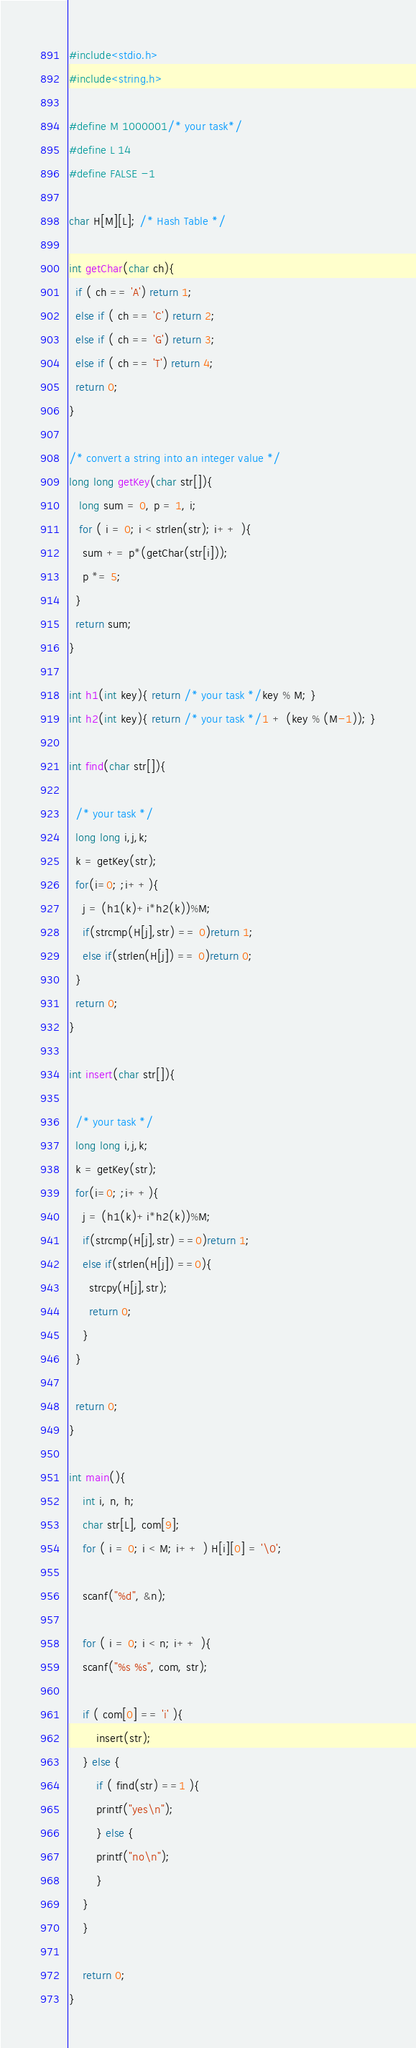Convert code to text. <code><loc_0><loc_0><loc_500><loc_500><_C_>#include<stdio.h>
#include<string.h>

#define M 1000001/* your task*/
#define L 14
#define FALSE -1

char H[M][L]; /* Hash Table */

int getChar(char ch){
  if ( ch == 'A') return 1;
  else if ( ch == 'C') return 2;
  else if ( ch == 'G') return 3;
  else if ( ch == 'T') return 4;
  return 0;
}

/* convert a string into an integer value */
long long getKey(char str[]){
   long sum = 0, p = 1, i;
   for ( i = 0; i < strlen(str); i++ ){
    sum += p*(getChar(str[i]));
    p *= 5;
  }
  return sum;
}

int h1(int key){ return /* your task */key % M; }
int h2(int key){ return /* your task */1 + (key % (M-1)); }

int find(char str[]){

  /* your task */
  long long i,j,k;
  k = getKey(str);
  for(i=0; ;i++){
    j = (h1(k)+i*h2(k))%M;
    if(strcmp(H[j],str) == 0)return 1;
    else if(strlen(H[j]) == 0)return 0;
  }
  return 0;
}

int insert(char str[]){

  /* your task */
  long long i,j,k;
  k = getKey(str);
  for(i=0; ;i++){
    j = (h1(k)+i*h2(k))%M;
    if(strcmp(H[j],str) ==0)return 1;
    else if(strlen(H[j]) ==0){
      strcpy(H[j],str);
      return 0;
    }
  }
  
  return 0;
}

int main(){
    int i, n, h;
    char str[L], com[9];
    for ( i = 0; i < M; i++ ) H[i][0] = '\0';
    
    scanf("%d", &n);
    
    for ( i = 0; i < n; i++ ){
	scanf("%s %s", com, str);
	
	if ( com[0] == 'i' ){
	    insert(str);
	} else {
	    if ( find(str) ==1 ){
		printf("yes\n");
	    } else {
		printf("no\n");
	    }
	}
    }

    return 0;
}

</code> 